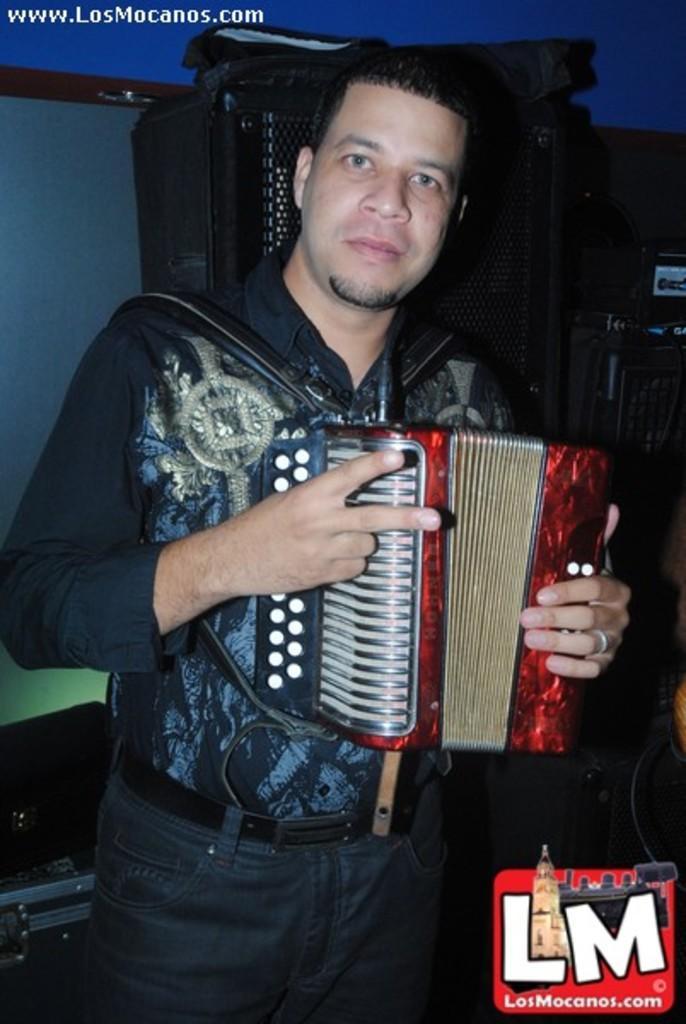Can you describe this image briefly? In this picture we can see a person holding an accordion in his hand. There is a watermark visible in the bottom right. We can see a few objects in the background. There is some text visible in the top left. 